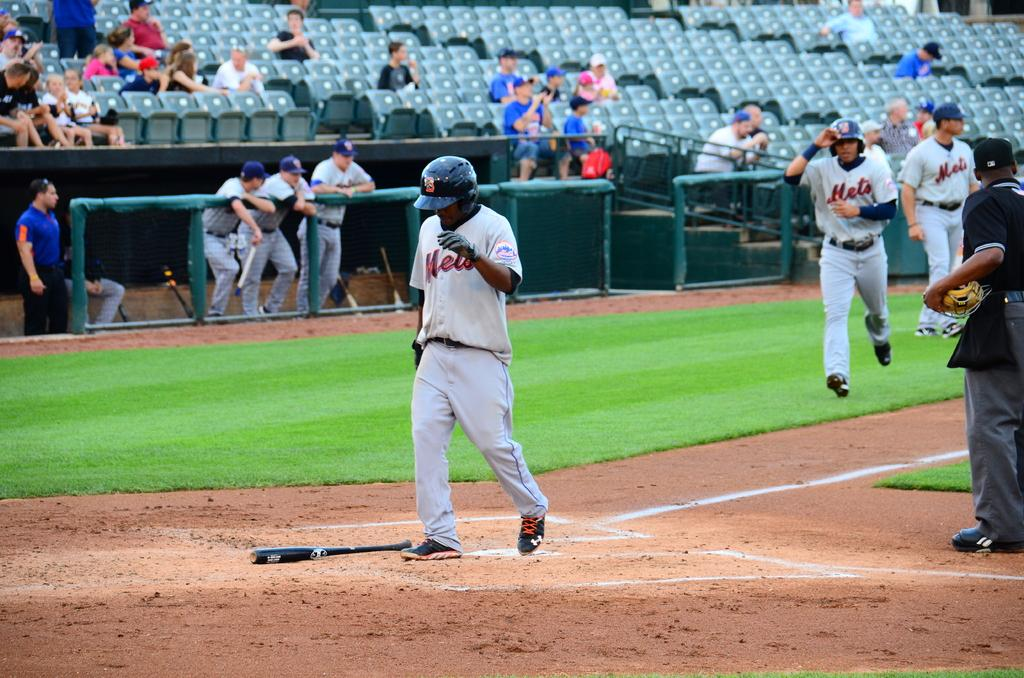<image>
Relay a brief, clear account of the picture shown. a player that has mets on his jersey 